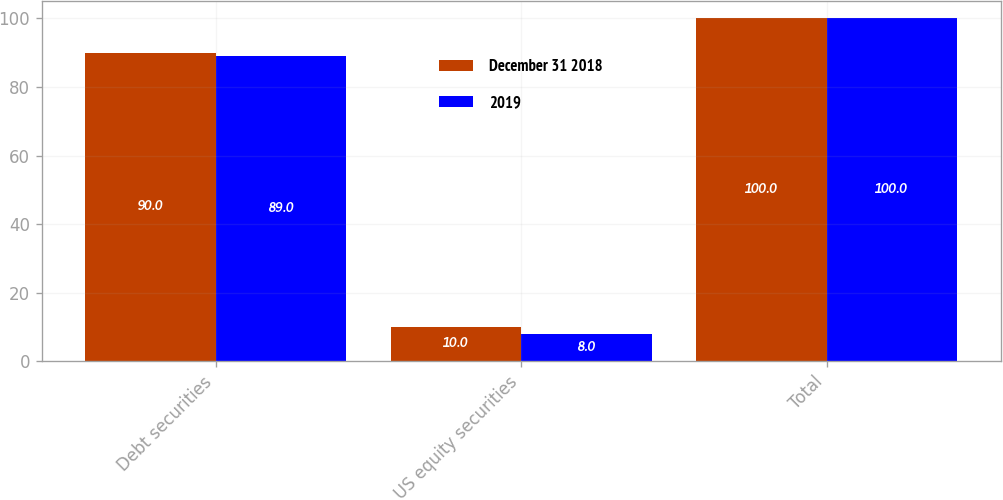<chart> <loc_0><loc_0><loc_500><loc_500><stacked_bar_chart><ecel><fcel>Debt securities<fcel>US equity securities<fcel>Total<nl><fcel>December 31 2018<fcel>90<fcel>10<fcel>100<nl><fcel>2019<fcel>89<fcel>8<fcel>100<nl></chart> 